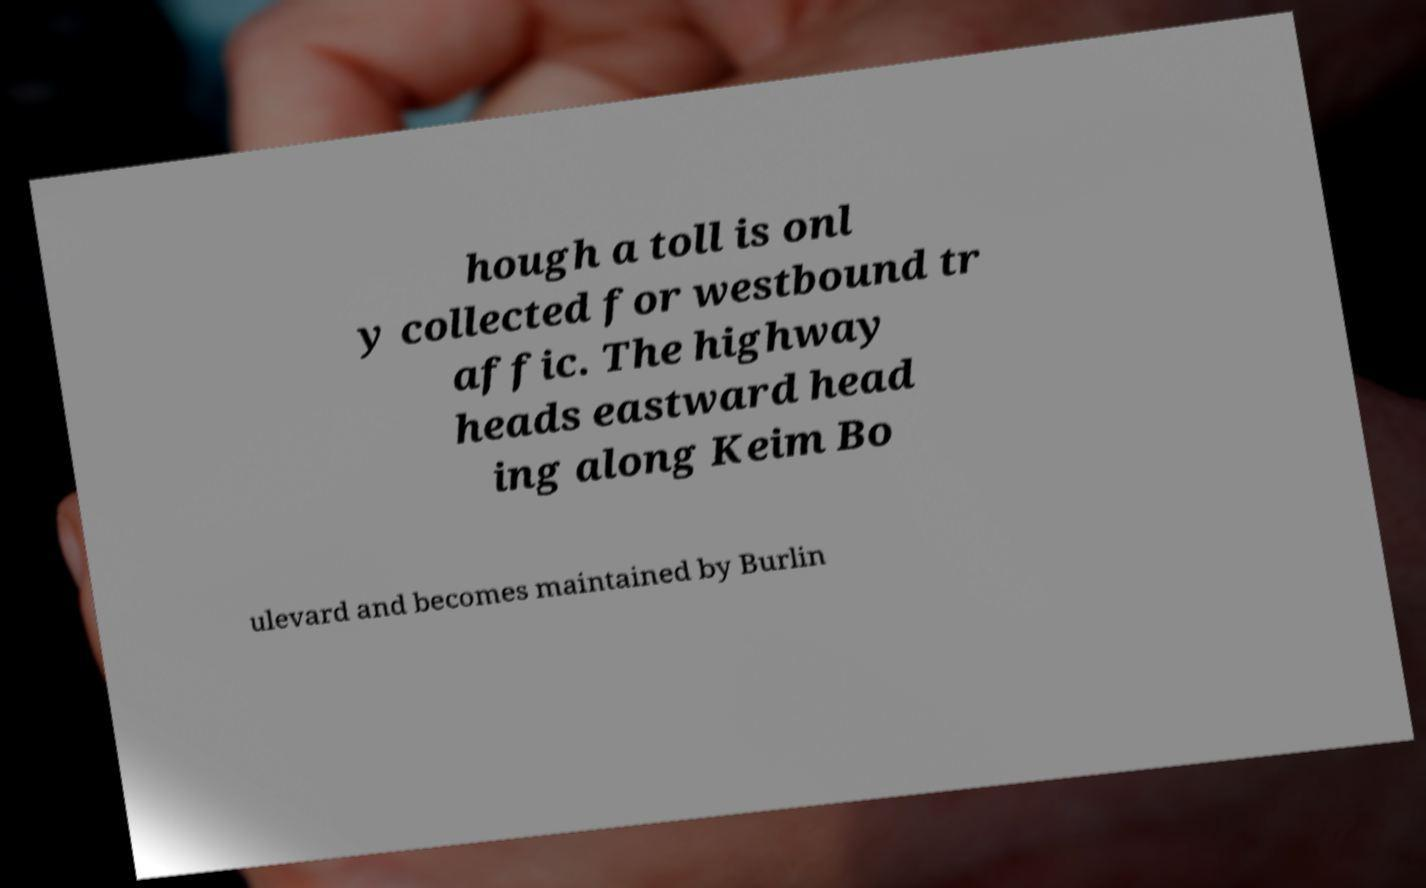Can you read and provide the text displayed in the image?This photo seems to have some interesting text. Can you extract and type it out for me? hough a toll is onl y collected for westbound tr affic. The highway heads eastward head ing along Keim Bo ulevard and becomes maintained by Burlin 